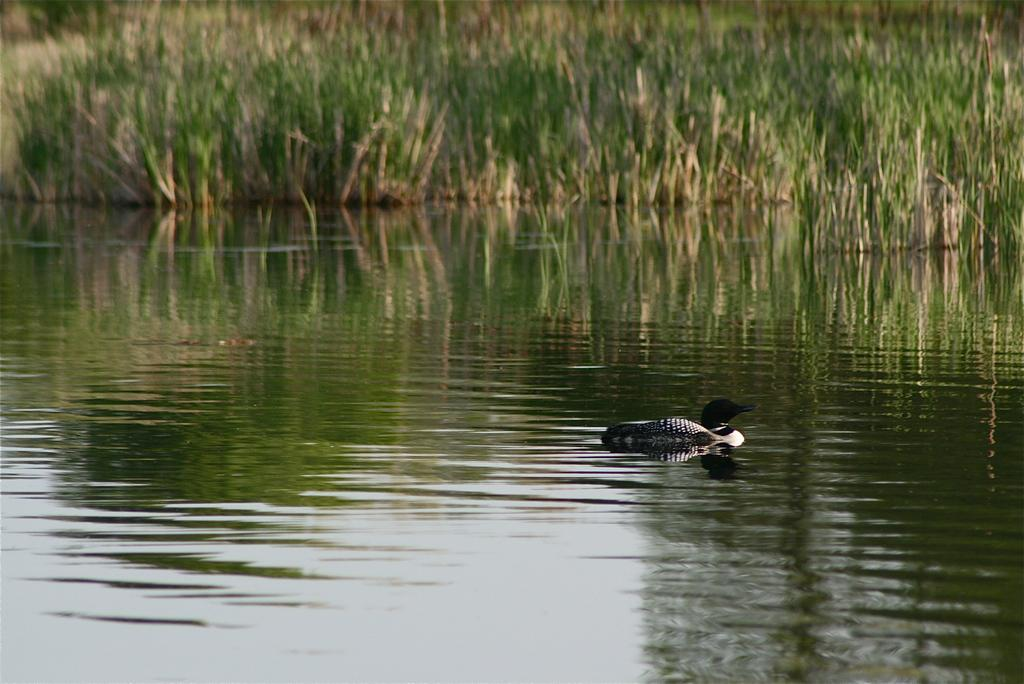What is the primary element in the image? There is water in the image. What is the animal doing in the water? The animal is swimming in the water. What type of vegetation can be seen in the image? There is green color grass visible in the image. What type of shoe is the animal wearing while swimming in the image? There is no shoe present in the image, as animals typically do not wear shoes while swimming. 